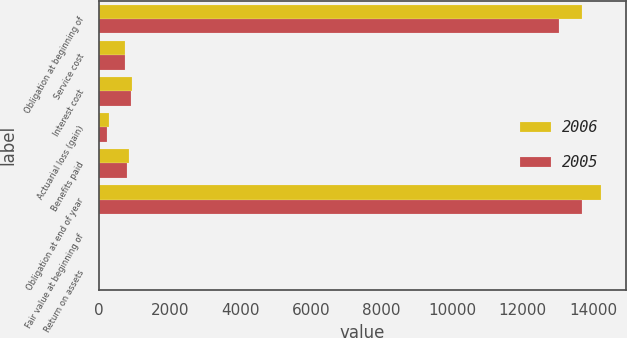Convert chart. <chart><loc_0><loc_0><loc_500><loc_500><stacked_bar_chart><ecel><fcel>Obligation at beginning of<fcel>Service cost<fcel>Interest cost<fcel>Actuarial loss (gain)<fcel>Benefits paid<fcel>Obligation at end of year<fcel>Fair value at beginning of<fcel>Return on assets<nl><fcel>2006<fcel>13680<fcel>731<fcel>927<fcel>278<fcel>856<fcel>14204<fcel>0<fcel>0<nl><fcel>2005<fcel>13040<fcel>735<fcel>891<fcel>211<fcel>775<fcel>13680<fcel>0<fcel>0<nl></chart> 